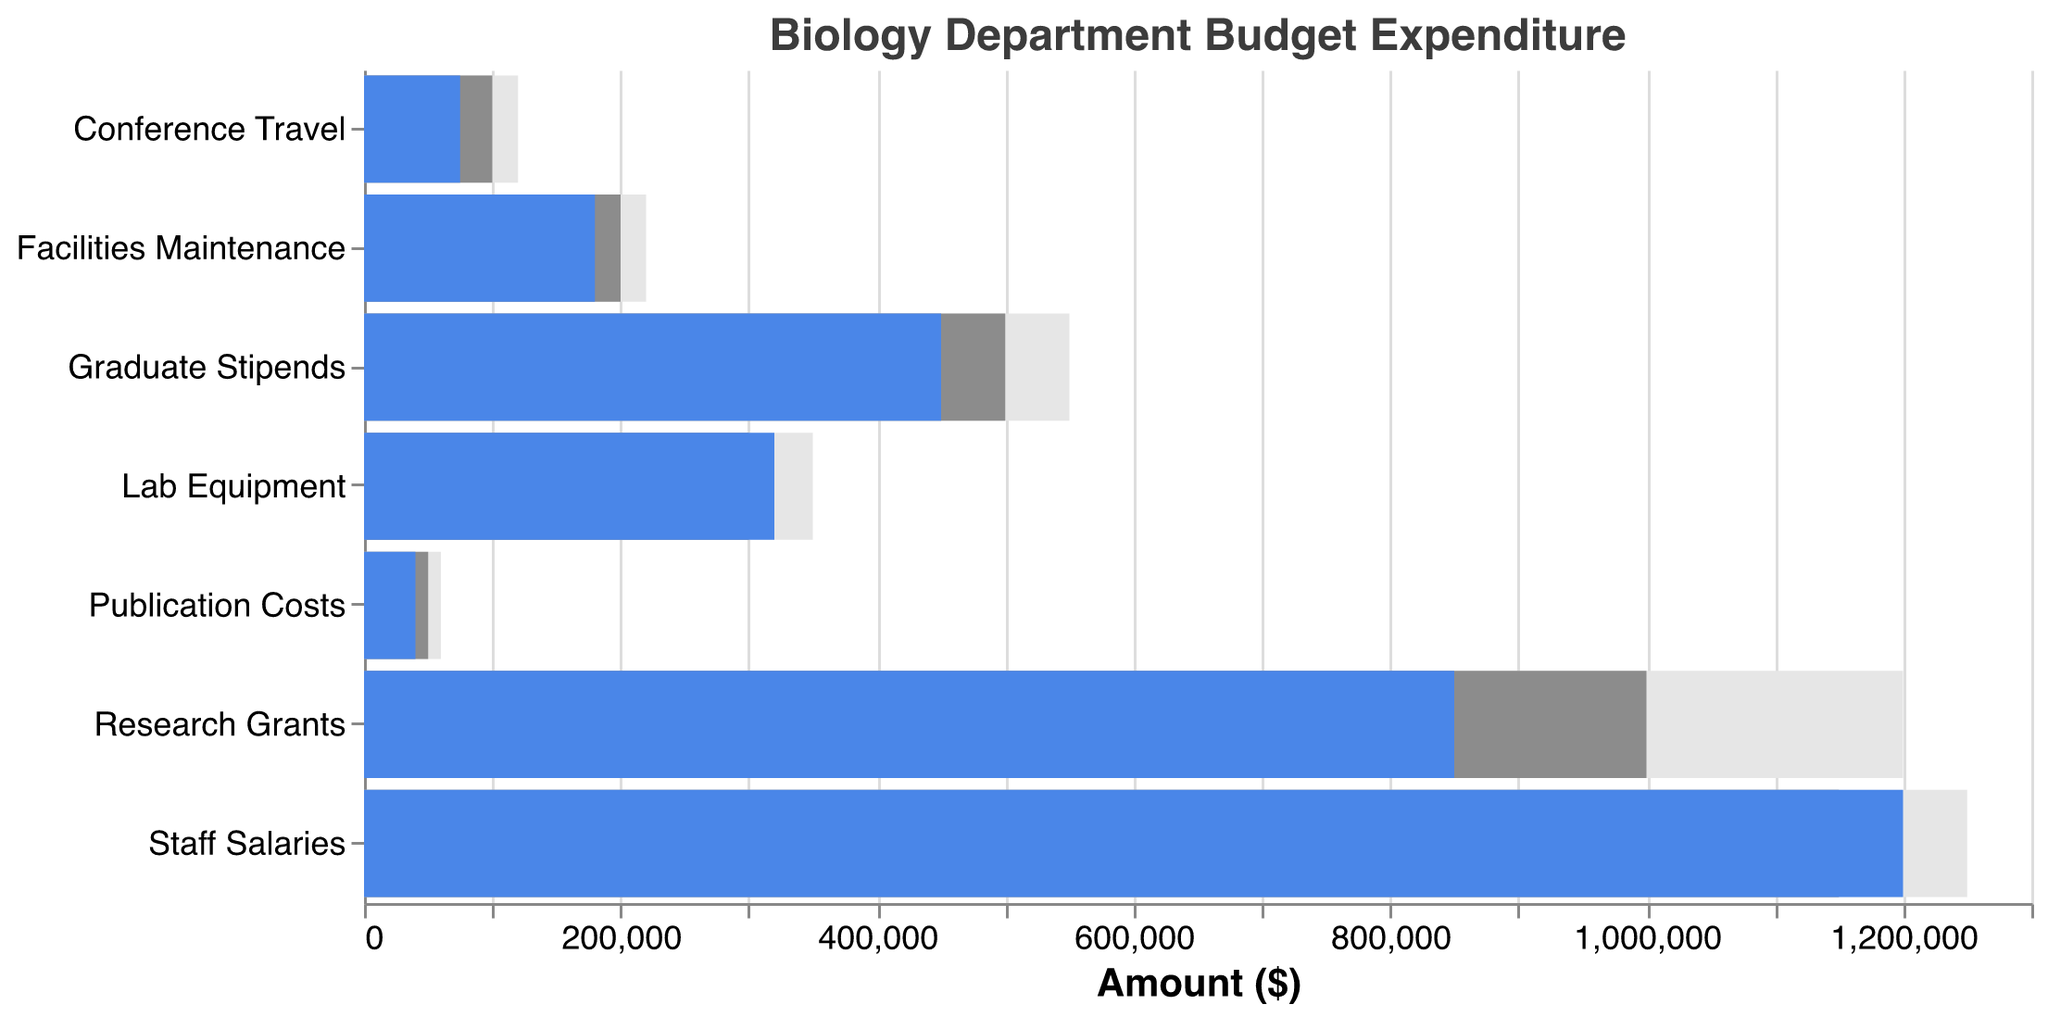What's the title of the figure? The title of the figure is situated at the top and usually summarizes the content of the visualization.
Answer: Biology Department Budget Expenditure How many categories of expenditures are displayed? By counting the number of unique categories listed on the vertical axis, we identify seven categories.
Answer: 7 Which category has the highest actual expenditure? Looking at the blue bar which represents actual expenditures, the Staff Salaries category has the highest value.
Answer: Staff Salaries What's the difference between the actual and budgeted expenditure for Lab Equipment? Subtract the actual expenditure (320,000) from the budgeted expenditure (300,000) for Lab Equipment.
Answer: 20,000 Compare the actual expenditure for Conference Travel to its target? The actual expenditure for Conference Travel is 75,000 and the target is 120,000. Subtract 75,000 from 120,000 to see the shortfall.
Answer: 45,000 Which expenditure category is closest to meeting its target? By comparing the lengths of the target (grey) and actual (blue) bars, Staff Salaries are closest to their target.
Answer: Staff Salaries For how many categories is the actual expenditure under the budgeted amount? Count the categories where the blue bar is shorter than the grey bar. Lab Equipment and Staff Salaries are among these categories.
Answer: 2 Is the actual expenditure on Research Grants closer to the budgeted or the target amount? Examine the lengths of the blue (850,000) vs. grey (1,000,000) and blue vs. the background (1,200,000). The actual expenditure is 150,000 under budget but 350,000 under the target, so it's closer to the budget.
Answer: Budgeted What's the sum of actual expenditures across all categories? Add all actual expenditures together: 850,000 + 320,000 + 1,200,000 + 75,000 + 450,000 + 40,000 + 180,000 = 3,115,000.
Answer: 3,115,000 Compare the actual and budgeted expenditures for Facilities Maintenance. Which is greater and by how much? The actual expenditure for Facilities Maintenance is 180,000, and the budgeted amount is 200,000. Subtract 180,000 from 200,000 to find the difference.
Answer: Budgeted by 20,000 